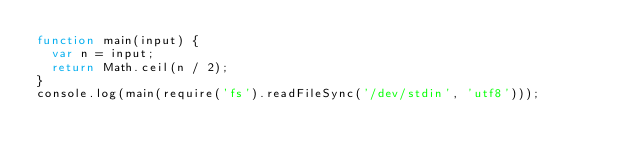<code> <loc_0><loc_0><loc_500><loc_500><_JavaScript_>function main(input) {
  var n = input;
  return Math.ceil(n / 2);
}
console.log(main(require('fs').readFileSync('/dev/stdin', 'utf8')));</code> 